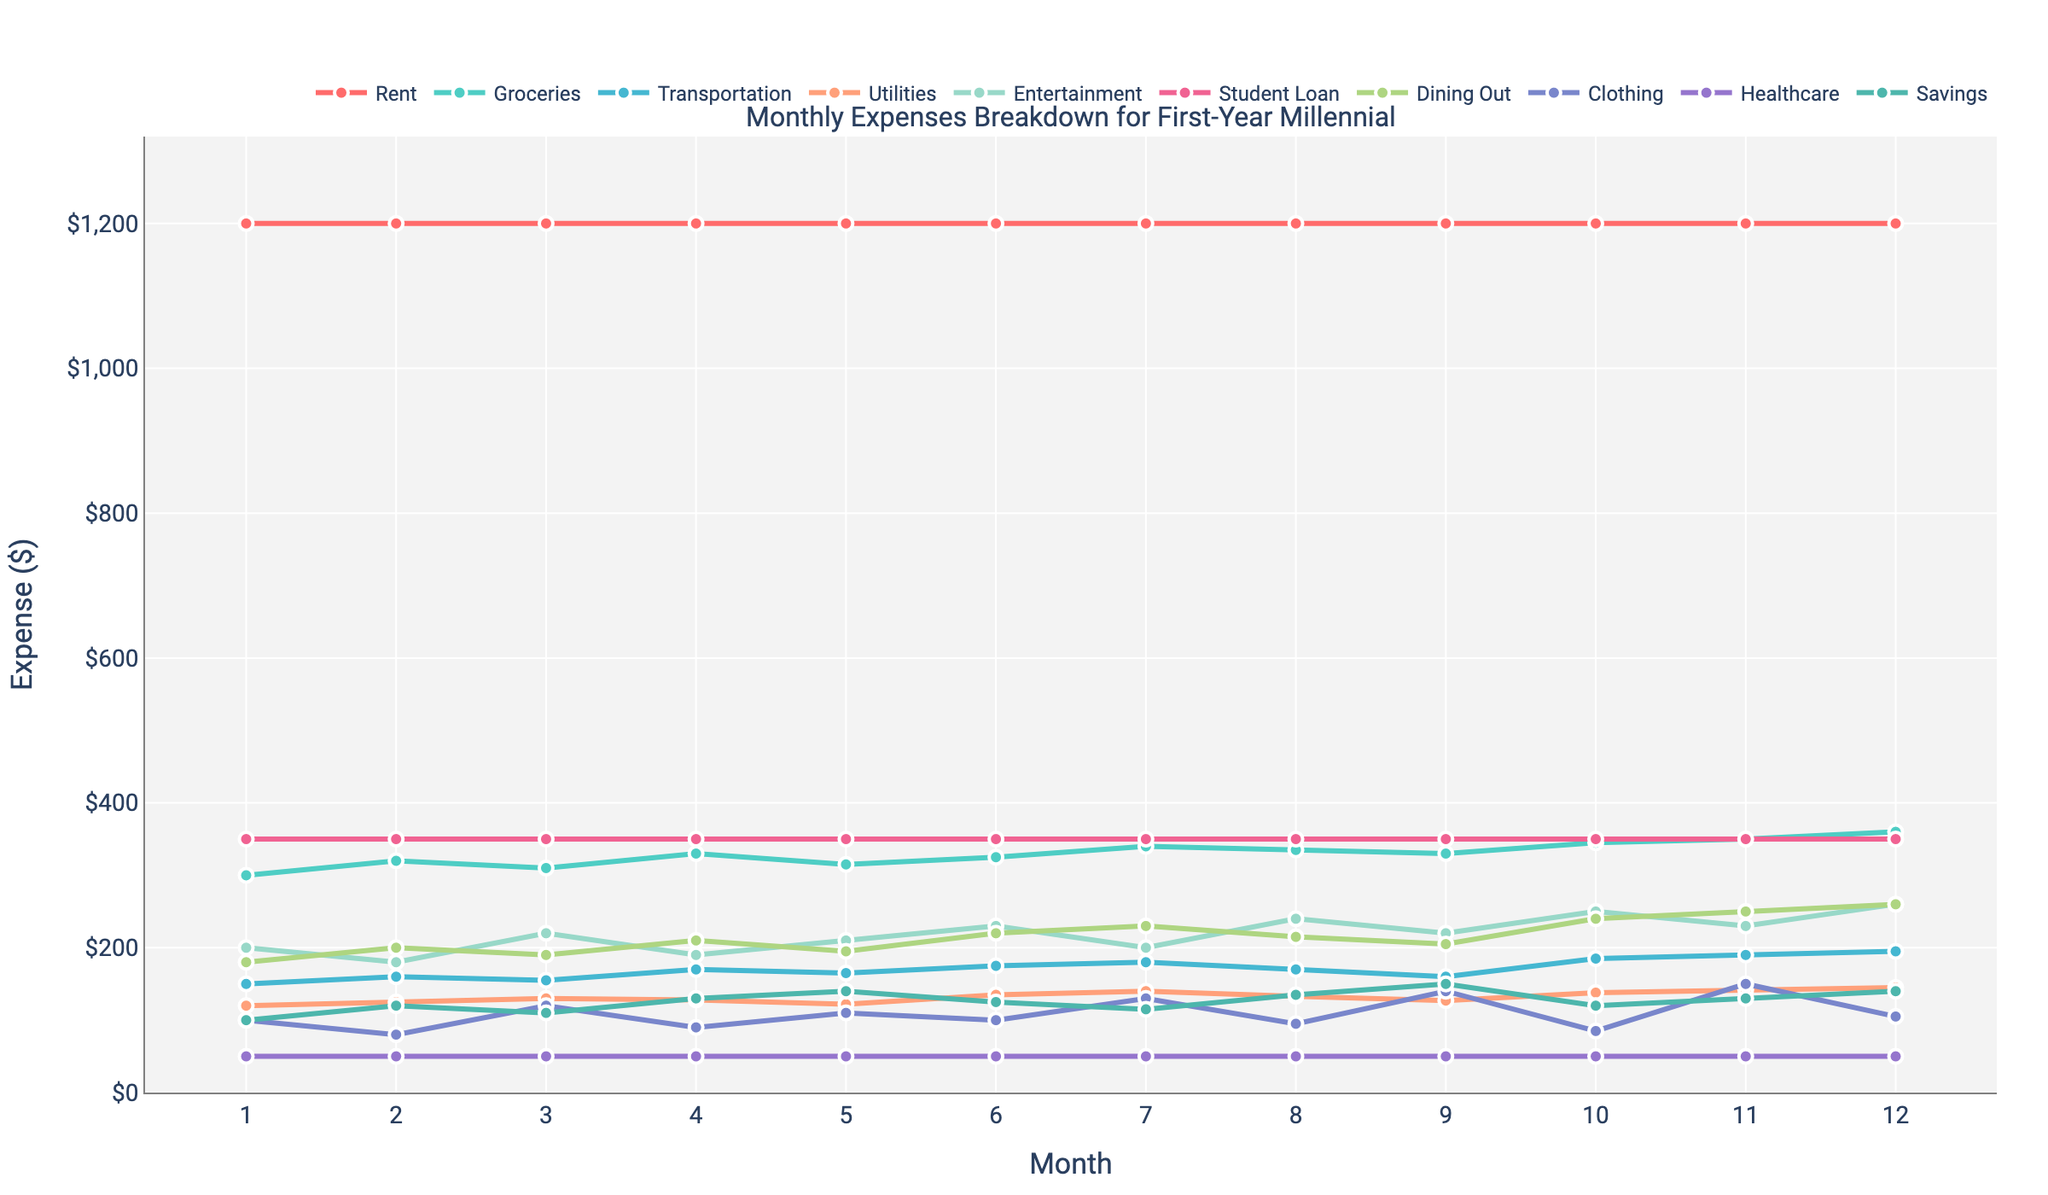What's the total monthly expense for Dining Out in the first 6 months? Sum the amounts for Dining Out from month 1 to month 6: 180 + 200 + 190 + 210 + 195 + 220 = 1195
Answer: 1195 Which month has the highest expense for Entertainment? Look at the data points for Entertainment in each month and find the highest value: Month 12 has the value 260
Answer: Month 12 How much more are monthly Groceries expenses in Month 12 compared to Month 1? Subtract the Groceries expense of Month 1 from that of Month 12: 360 - 300 = 60
Answer: 60 During which month are Transportation expenses the lowest? Review the Transportation data points and find the smallest value: Both Month 2 and Month 9 have the lowest expense, which is 160
Answer: Month 9 What's the average monthly expense for Utilities throughout the year? Calculate the sum of all Utilities expenses and then divide by 12: (120 + 125 + 130 + 128 + 122 + 135 + 140 + 133 + 127 + 138 + 142 + 145) / 12 = 137.67
Answer: 137.67 Is Groceries expense higher in Month 5 or Month 8? Compare the Grocery expenditures of Month 5 and Month 8: 315 (Month 5) < 335 (Month 8)
Answer: Month 8 Which category has the highest expense on average per month? Average each category's monthly expense and compare: Rent is 1200 each month, which is the highest constant value across all categories
Answer: Rent Do the monthly expenses on Student Loan change? Examine the data points for Student Loan in each month; it remains constant at 350
Answer: No Are Savings more in Month 6 or Month 10? Compare the Savings data points for Month 6 and Month 10: 125 (Month 6) > 120 (Month 10)
Answer: Month 6 Which month has the highest overall expense combining all categories? Summarize all expenses for each month and compare: Month 12 has the highest total (2760) from summing the different categories
Answer: Month 12 